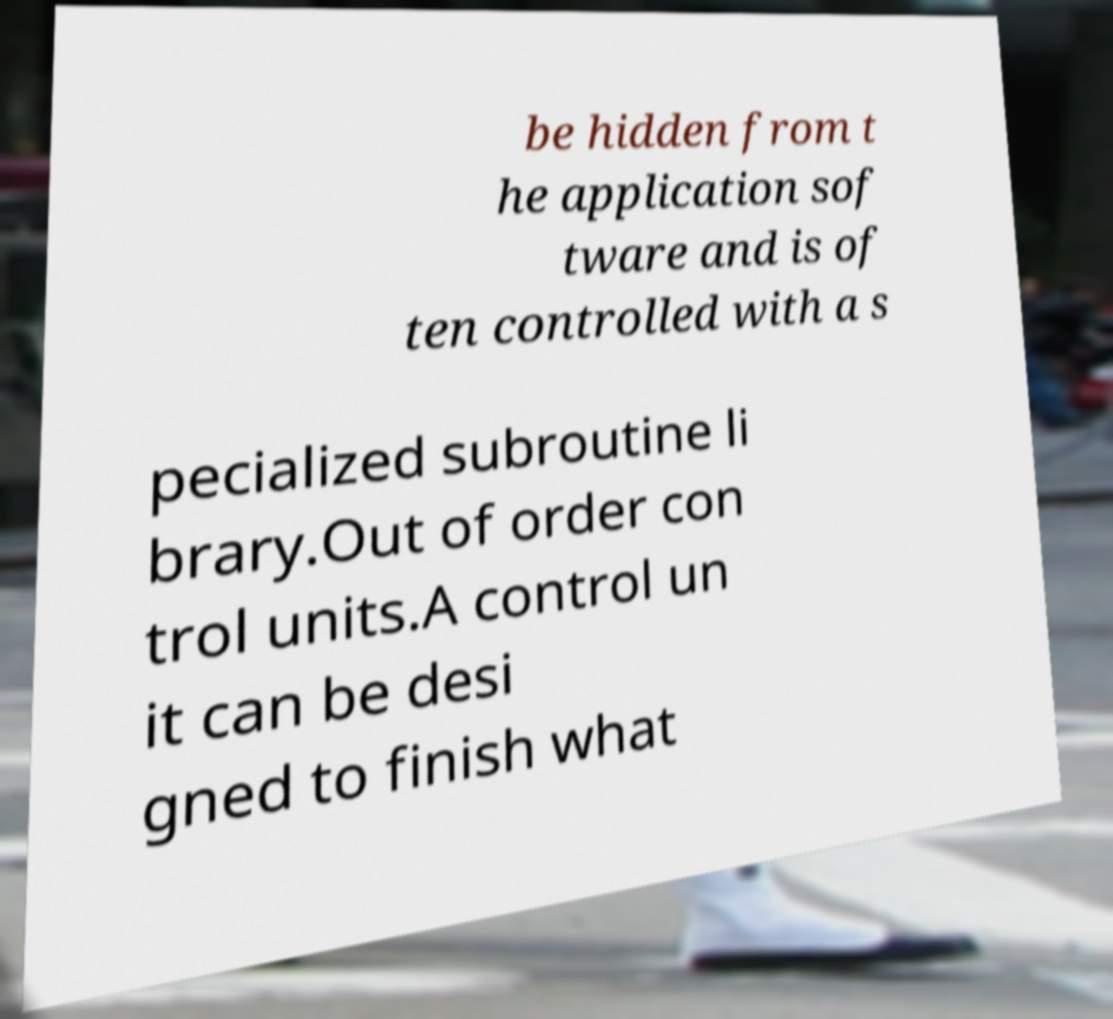Please identify and transcribe the text found in this image. be hidden from t he application sof tware and is of ten controlled with a s pecialized subroutine li brary.Out of order con trol units.A control un it can be desi gned to finish what 